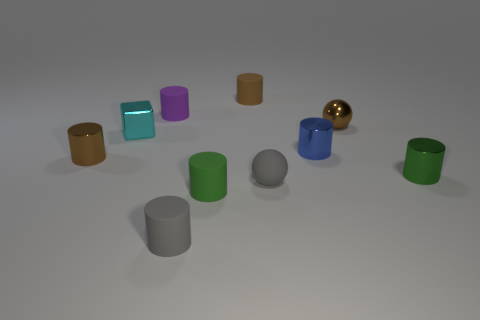Does the matte sphere have the same color as the tiny rubber object in front of the tiny green matte cylinder?
Your response must be concise. Yes. There is a metallic thing that is both right of the blue metallic object and in front of the tiny cyan metal thing; how big is it?
Your answer should be compact. Small. What number of other things are there of the same color as the metallic sphere?
Offer a terse response. 2. There is a green shiny thing to the right of the brown thing that is to the left of the small rubber thing left of the gray cylinder; what size is it?
Keep it short and to the point. Small. There is a purple cylinder; are there any matte cylinders in front of it?
Ensure brevity in your answer.  Yes. There is a gray cylinder; is its size the same as the metallic block behind the gray sphere?
Offer a terse response. Yes. What number of other things are there of the same material as the tiny gray ball
Provide a succinct answer. 4. There is a thing that is behind the metallic sphere and to the right of the small green rubber object; what is its shape?
Make the answer very short. Cylinder. Is the size of the gray thing left of the small green matte cylinder the same as the green thing that is in front of the tiny gray ball?
Make the answer very short. Yes. There is a small blue object that is the same material as the cyan object; what is its shape?
Ensure brevity in your answer.  Cylinder. 